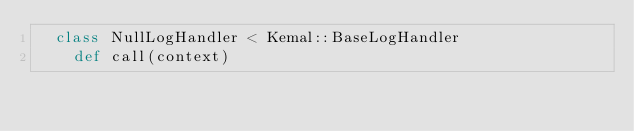<code> <loc_0><loc_0><loc_500><loc_500><_Crystal_>  class NullLogHandler < Kemal::BaseLogHandler
    def call(context)</code> 